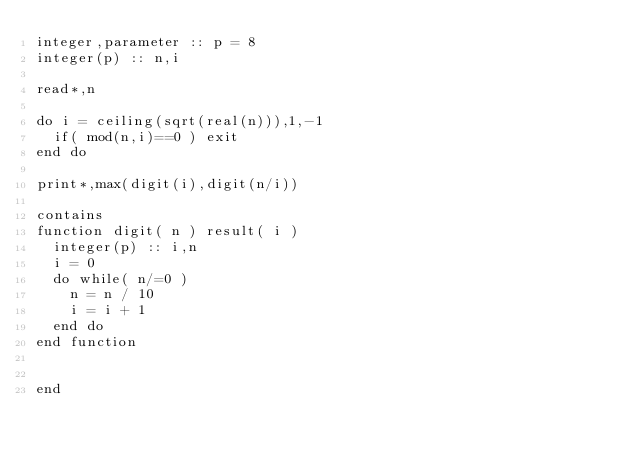Convert code to text. <code><loc_0><loc_0><loc_500><loc_500><_FORTRAN_>integer,parameter :: p = 8
integer(p) :: n,i

read*,n

do i = ceiling(sqrt(real(n))),1,-1
  if( mod(n,i)==0 ) exit
end do

print*,max(digit(i),digit(n/i))

contains
function digit( n ) result( i )
  integer(p) :: i,n
  i = 0
  do while( n/=0 )
    n = n / 10
    i = i + 1
  end do
end function
    

end
</code> 